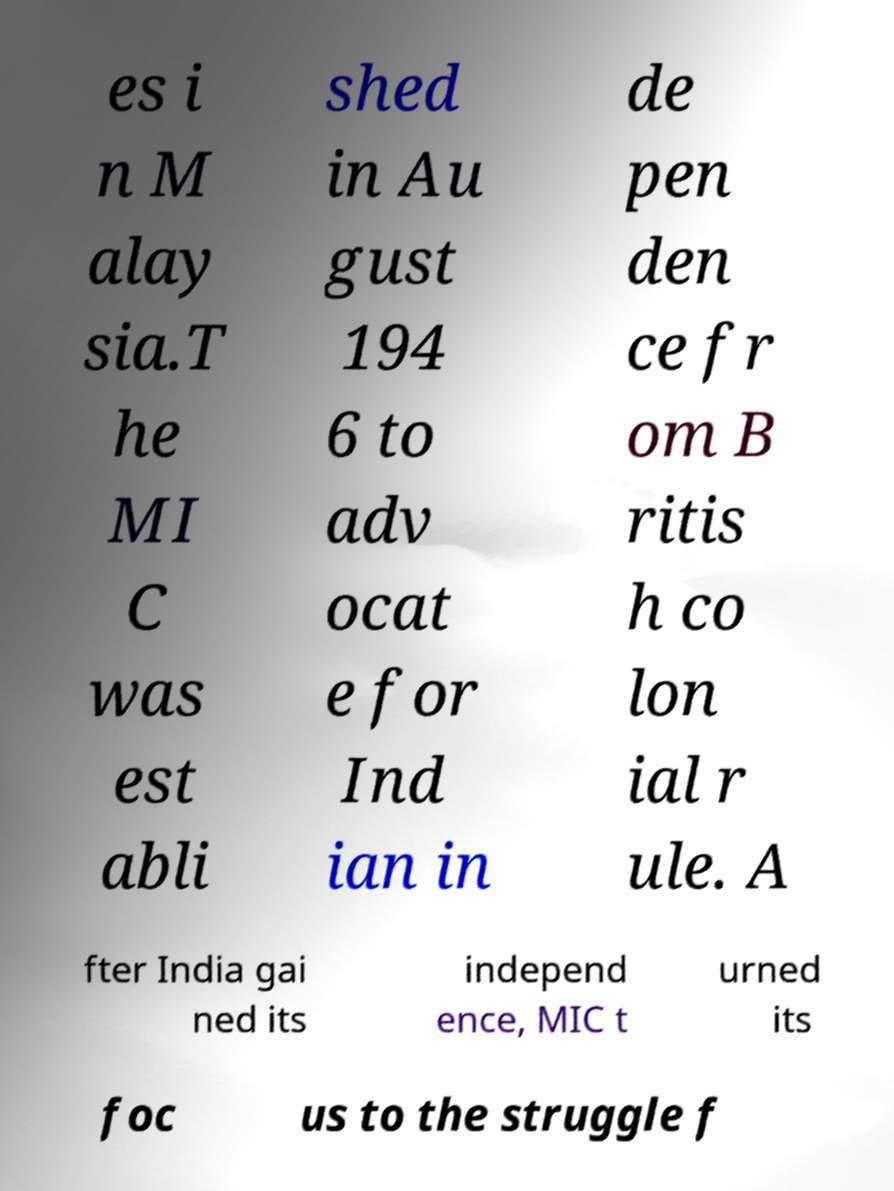There's text embedded in this image that I need extracted. Can you transcribe it verbatim? es i n M alay sia.T he MI C was est abli shed in Au gust 194 6 to adv ocat e for Ind ian in de pen den ce fr om B ritis h co lon ial r ule. A fter India gai ned its independ ence, MIC t urned its foc us to the struggle f 